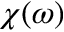<formula> <loc_0><loc_0><loc_500><loc_500>\chi ( \omega )</formula> 